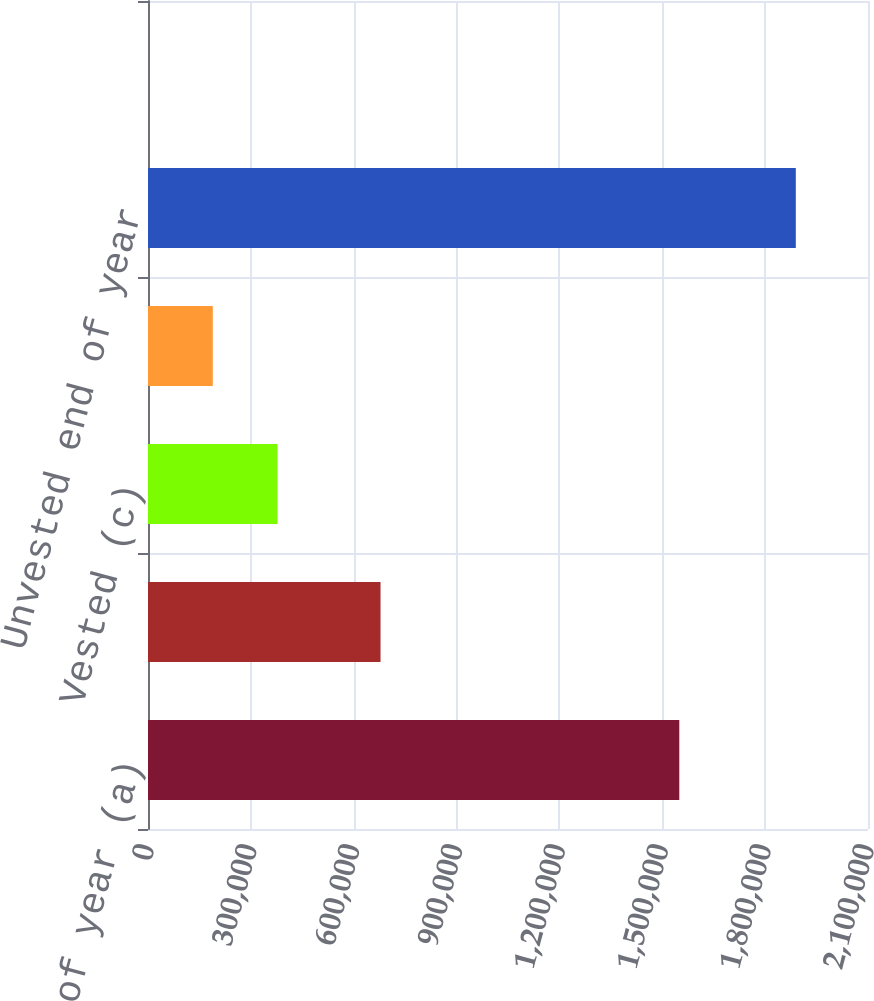<chart> <loc_0><loc_0><loc_500><loc_500><bar_chart><fcel>Unvested beginning of year (a)<fcel>Granted (b)<fcel>Vested (c)<fcel>Forfeited<fcel>Unvested end of year<fcel>Net compensation expense for<nl><fcel>1.54962e+06<fcel>678188<fcel>377912<fcel>188971<fcel>1.88943e+06<fcel>31<nl></chart> 